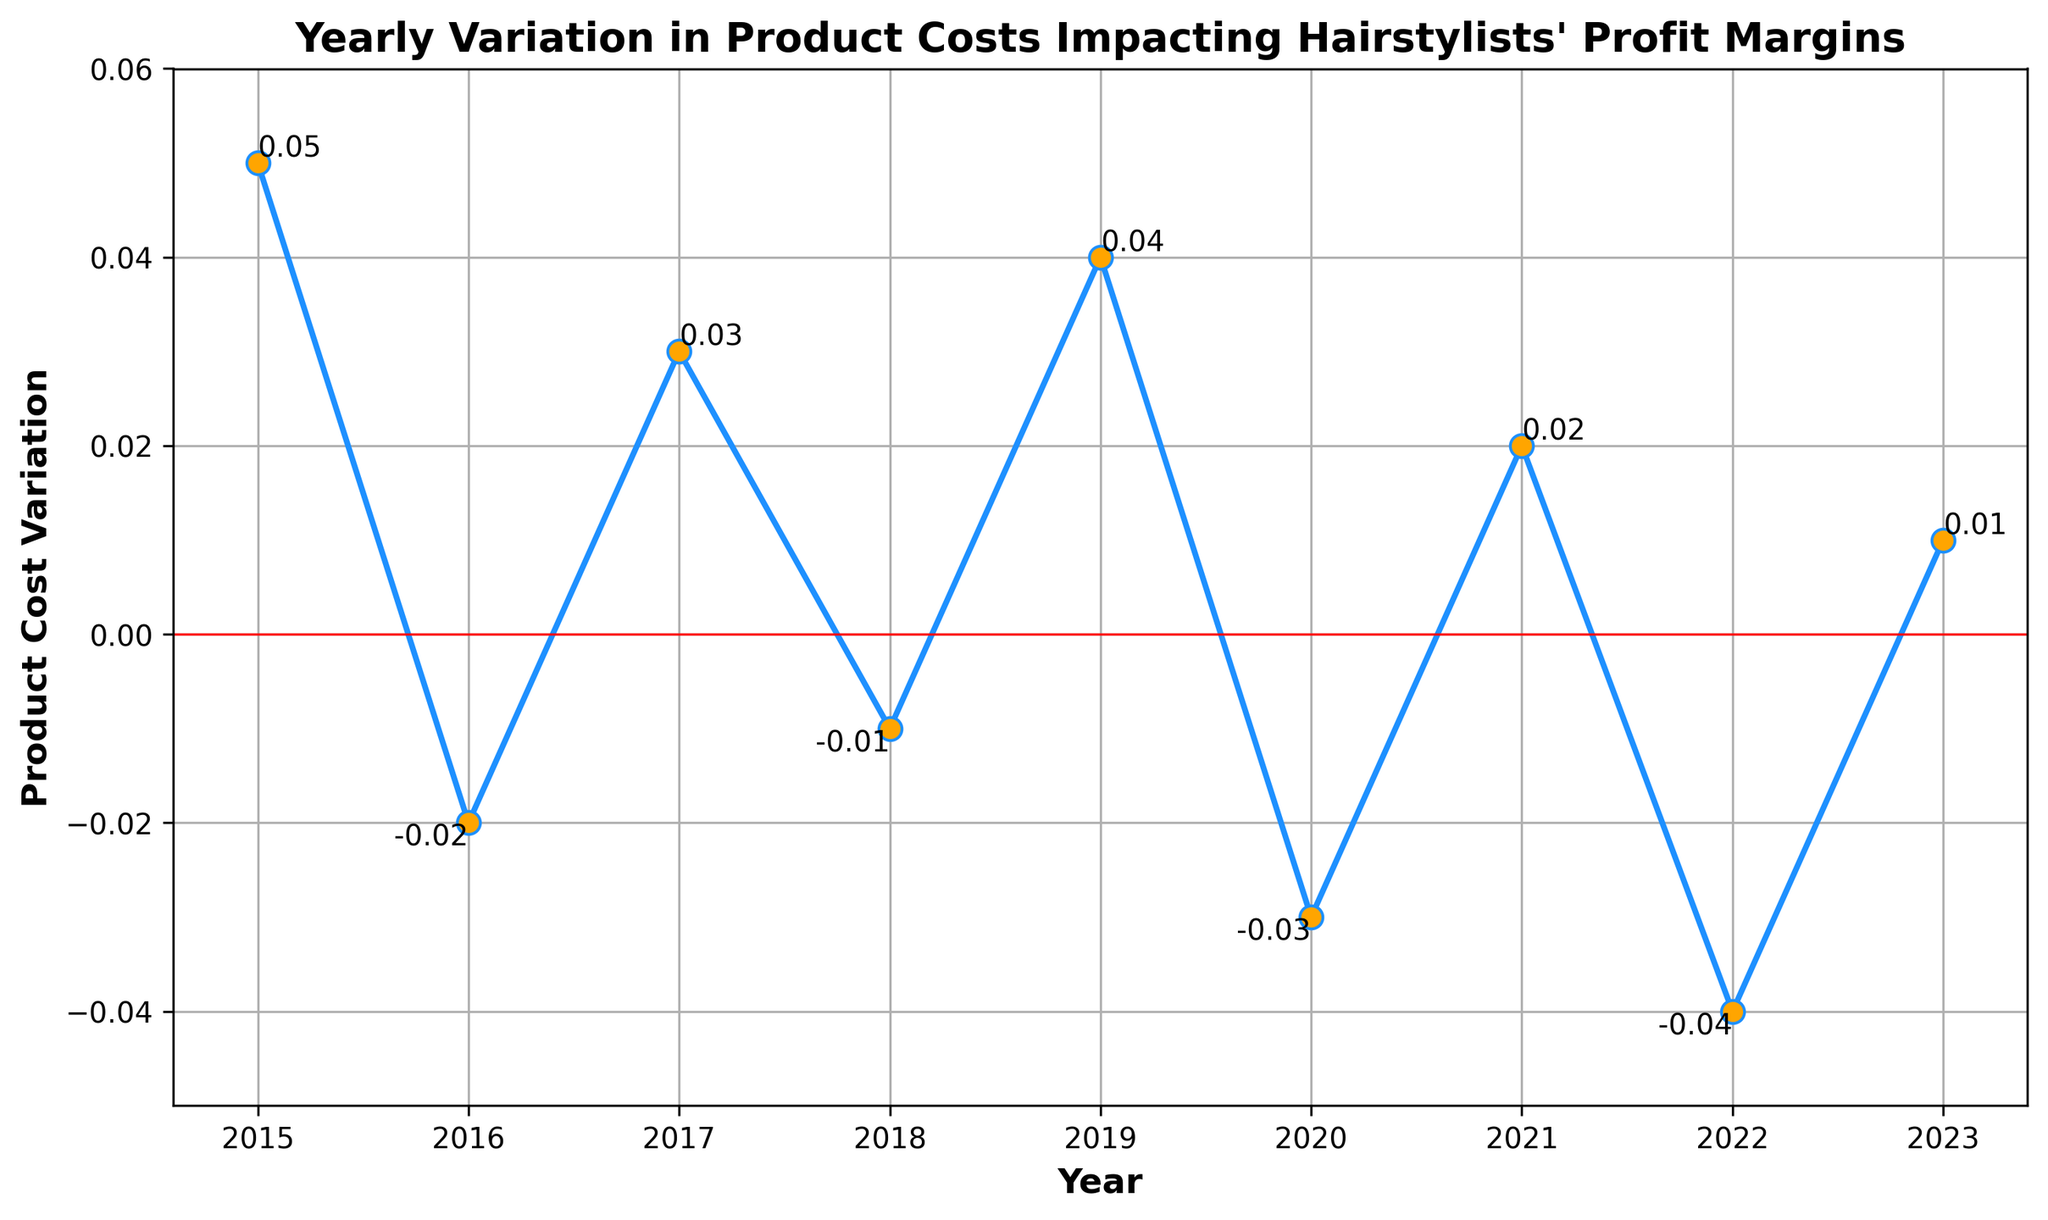Which year had the highest positive variation in product costs? To determine the highest positive variation, observe the data points above the zero line and compare their heights. The highest positive variation is in 2015 with a value of 0.05.
Answer: 2015 In which years did the product cost variation have a negative impact on profit margins? Negative impact is indicated by values below the zero line. From the plot, these values appear in the years 2016, 2018, 2020, and 2022.
Answer: 2016, 2018, 2020, 2022 What is the average product cost variation from 2015 to 2023? To find the average, sum up all the variations and divide by the number of years: (0.05 + -0.02 + 0.03 + -0.01 + 0.04 + -0.03 + 0.02 + -0.04 + 0.01) / 9 = 0.0056, approximately.
Answer: Approximately 0.006 Compare the product cost variations in 2016 and 2020. Which year had a greater negative impact? Look at the values for both years. In 2016, it’s -0.02, and in 2020, it’s -0.03. Since -0.03 is more negative than -0.02, 2020 had a greater negative impact.
Answer: 2020 Which year saw the smallest variation in product costs? The smallest variation (absolute value closest to zero) occurred in 2018 with a value of -0.01.
Answer: 2018 What was the total variation in product costs over the entire period? Total variation is the sum of all yearly variations: 0.05 + -0.02 + 0.03 + -0.01 + 0.04 + -0.03 + 0.02 + -0.04 + 0.01 = 0.05
Answer: 0.05 Identify the years with variations at and above 0.04. These variations occurred in 2015 and 2019, as both years had a variation of 0.05 and 0.04 respectively.
Answer: 2015, 2019 Between 2017 and 2021, which year had the highest positive variation? Compare the values from 2017 to 2021. The highest positive variation in this range occurred in 2017 with 0.03.
Answer: 2017 